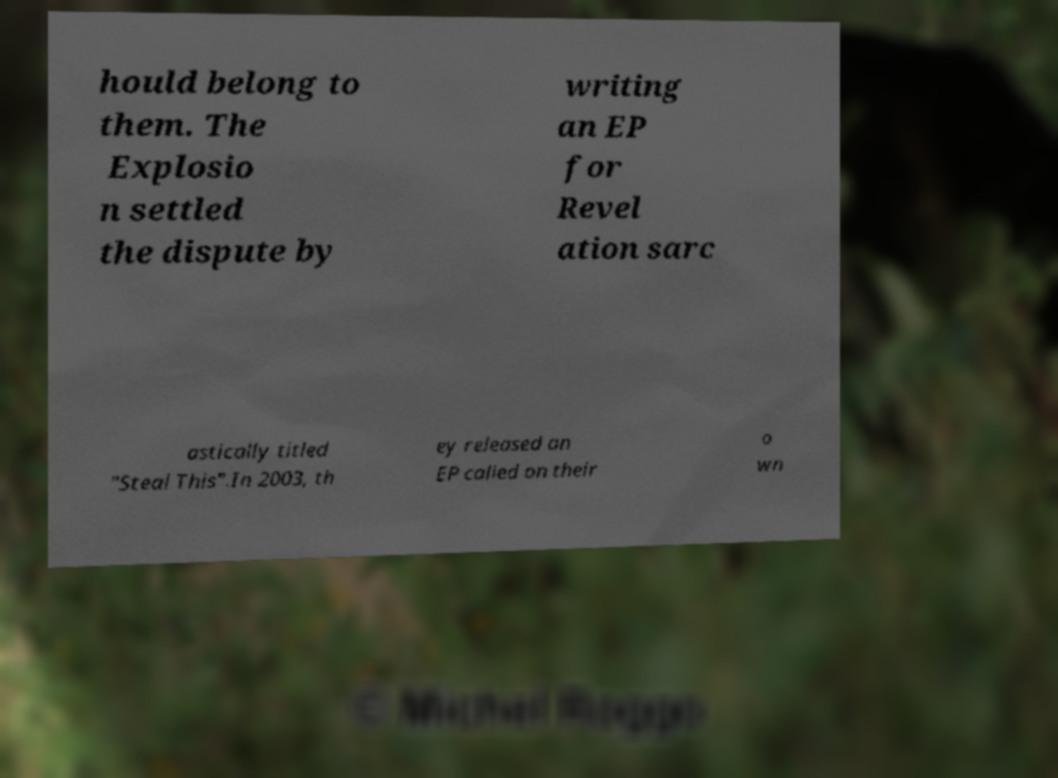Please identify and transcribe the text found in this image. hould belong to them. The Explosio n settled the dispute by writing an EP for Revel ation sarc astically titled "Steal This".In 2003, th ey released an EP called on their o wn 